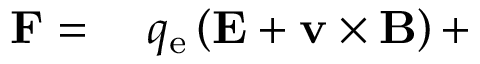<formula> <loc_0><loc_0><loc_500><loc_500>\begin{array} { r l } { F } & q _ { e } \left ( E + v \times B \right ) + } \end{array}</formula> 